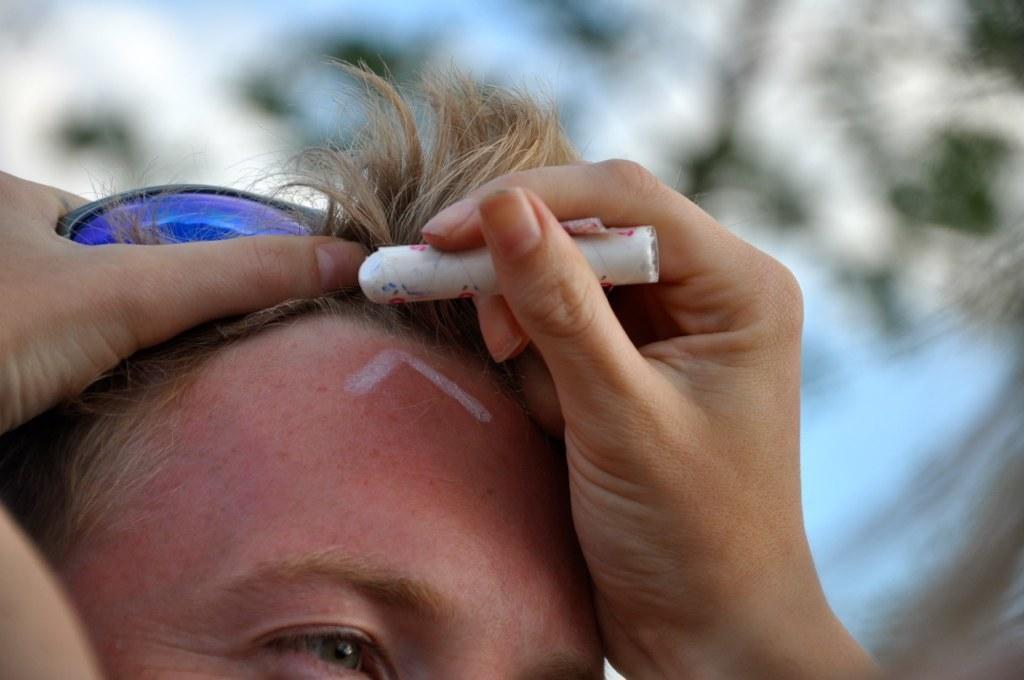Please provide a concise description of this image. In this picture there is a man who is wearing goggles. On the left we can see another person's hands who is holding chalk. At the top there is a sky. On the right we can see the tree. 